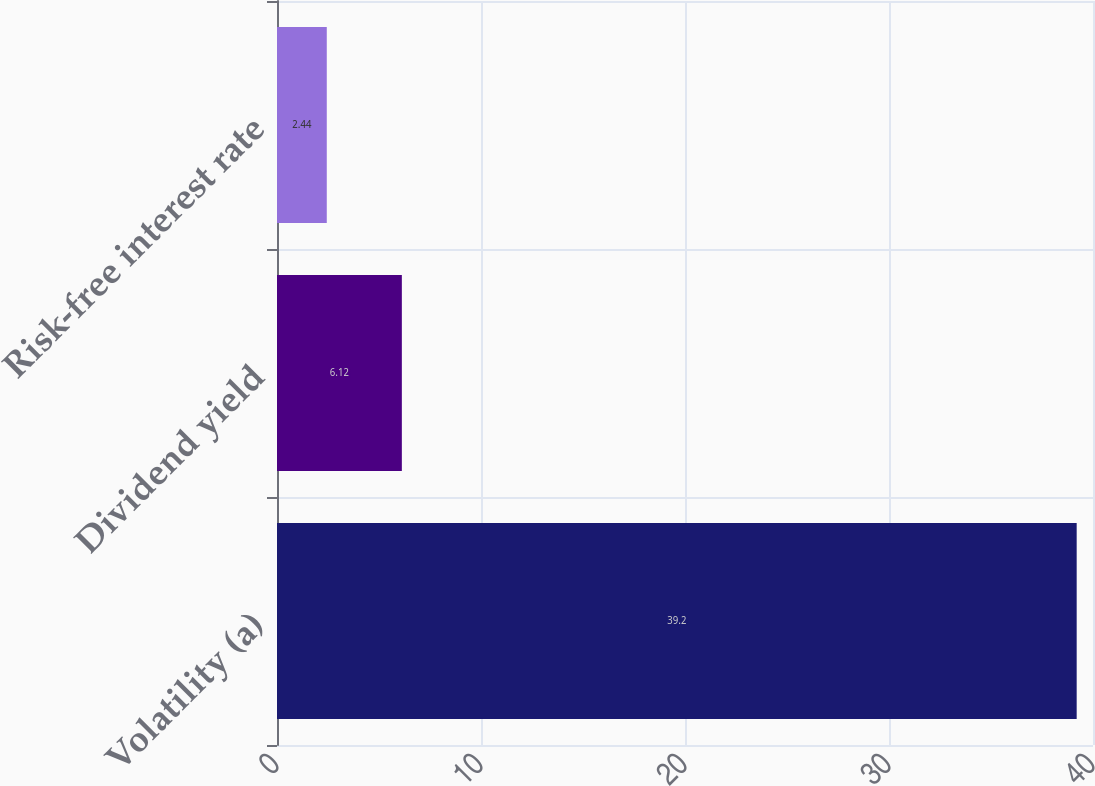Convert chart. <chart><loc_0><loc_0><loc_500><loc_500><bar_chart><fcel>Volatility (a)<fcel>Dividend yield<fcel>Risk-free interest rate<nl><fcel>39.2<fcel>6.12<fcel>2.44<nl></chart> 